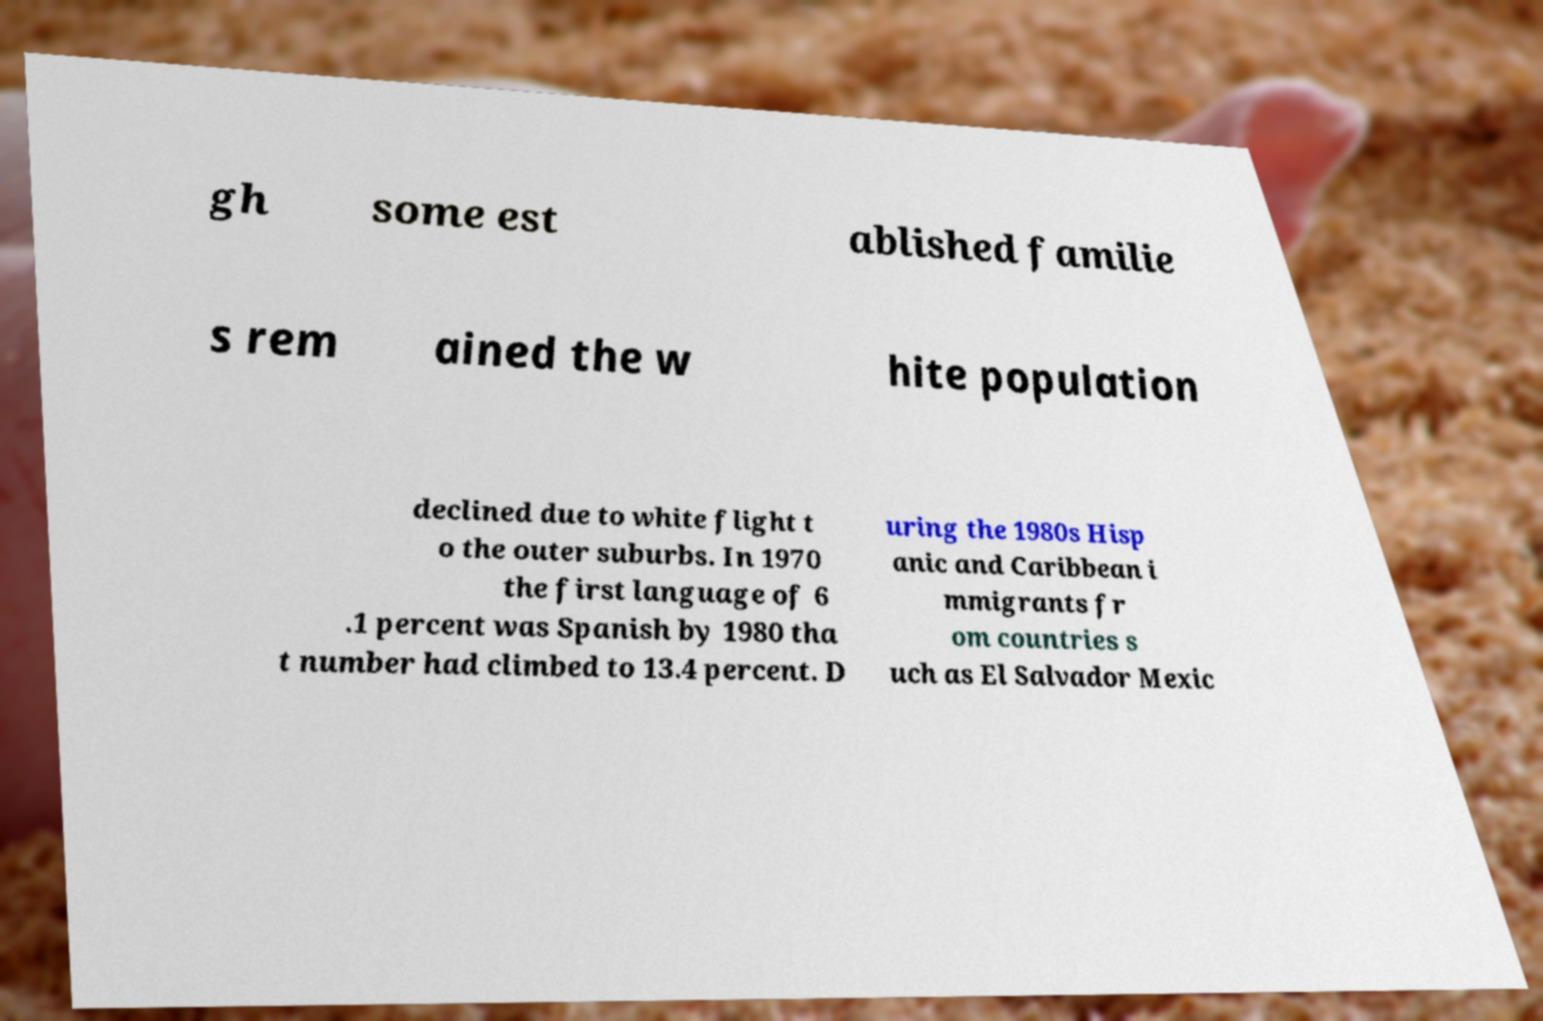There's text embedded in this image that I need extracted. Can you transcribe it verbatim? gh some est ablished familie s rem ained the w hite population declined due to white flight t o the outer suburbs. In 1970 the first language of 6 .1 percent was Spanish by 1980 tha t number had climbed to 13.4 percent. D uring the 1980s Hisp anic and Caribbean i mmigrants fr om countries s uch as El Salvador Mexic 